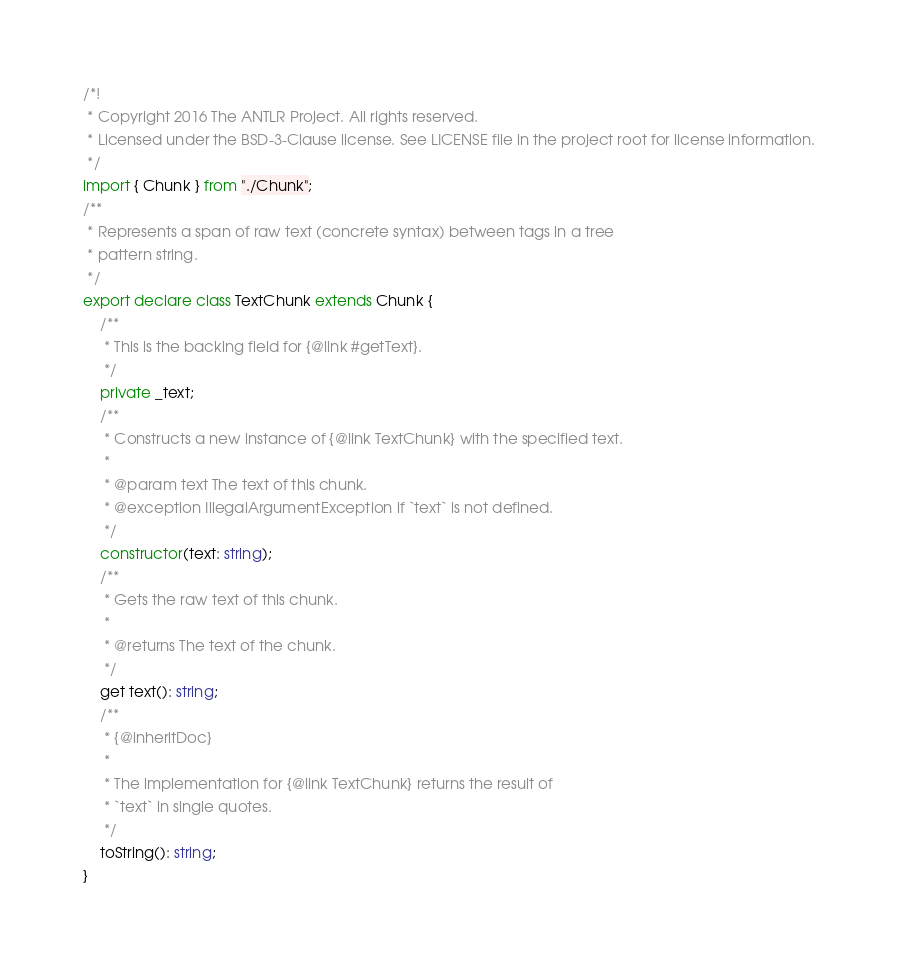<code> <loc_0><loc_0><loc_500><loc_500><_TypeScript_>/*!
 * Copyright 2016 The ANTLR Project. All rights reserved.
 * Licensed under the BSD-3-Clause license. See LICENSE file in the project root for license information.
 */
import { Chunk } from "./Chunk";
/**
 * Represents a span of raw text (concrete syntax) between tags in a tree
 * pattern string.
 */
export declare class TextChunk extends Chunk {
    /**
     * This is the backing field for {@link #getText}.
     */
    private _text;
    /**
     * Constructs a new instance of {@link TextChunk} with the specified text.
     *
     * @param text The text of this chunk.
     * @exception IllegalArgumentException if `text` is not defined.
     */
    constructor(text: string);
    /**
     * Gets the raw text of this chunk.
     *
     * @returns The text of the chunk.
     */
    get text(): string;
    /**
     * {@inheritDoc}
     *
     * The implementation for {@link TextChunk} returns the result of
     * `text` in single quotes.
     */
    toString(): string;
}
</code> 